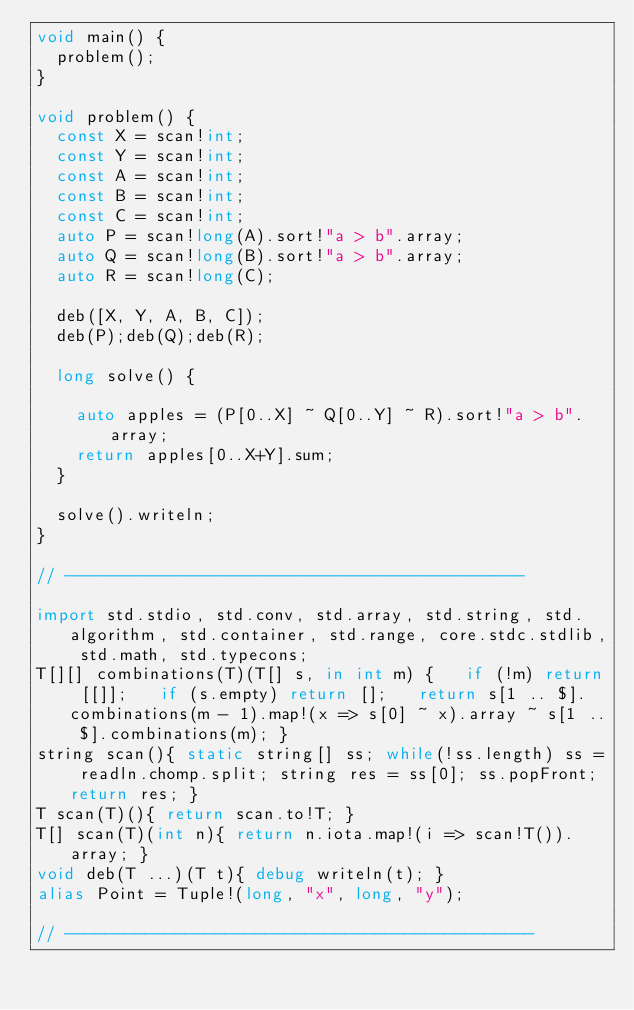Convert code to text. <code><loc_0><loc_0><loc_500><loc_500><_D_>void main() {
  problem();
}

void problem() {
  const X = scan!int;
  const Y = scan!int;
  const A = scan!int;
  const B = scan!int;
  const C = scan!int;
  auto P = scan!long(A).sort!"a > b".array;
  auto Q = scan!long(B).sort!"a > b".array;
  auto R = scan!long(C);
  
  deb([X, Y, A, B, C]);
  deb(P);deb(Q);deb(R);

  long solve() {

    auto apples = (P[0..X] ~ Q[0..Y] ~ R).sort!"a > b".array;
    return apples[0..X+Y].sum;
  }

  solve().writeln;
}

// ----------------------------------------------

import std.stdio, std.conv, std.array, std.string, std.algorithm, std.container, std.range, core.stdc.stdlib, std.math, std.typecons;
T[][] combinations(T)(T[] s, in int m) {   if (!m) return [[]];   if (s.empty) return [];   return s[1 .. $].combinations(m - 1).map!(x => s[0] ~ x).array ~ s[1 .. $].combinations(m); }
string scan(){ static string[] ss; while(!ss.length) ss = readln.chomp.split; string res = ss[0]; ss.popFront; return res; }
T scan(T)(){ return scan.to!T; }
T[] scan(T)(int n){ return n.iota.map!(i => scan!T()).array; }
void deb(T ...)(T t){ debug writeln(t); }
alias Point = Tuple!(long, "x", long, "y");

// -----------------------------------------------
</code> 